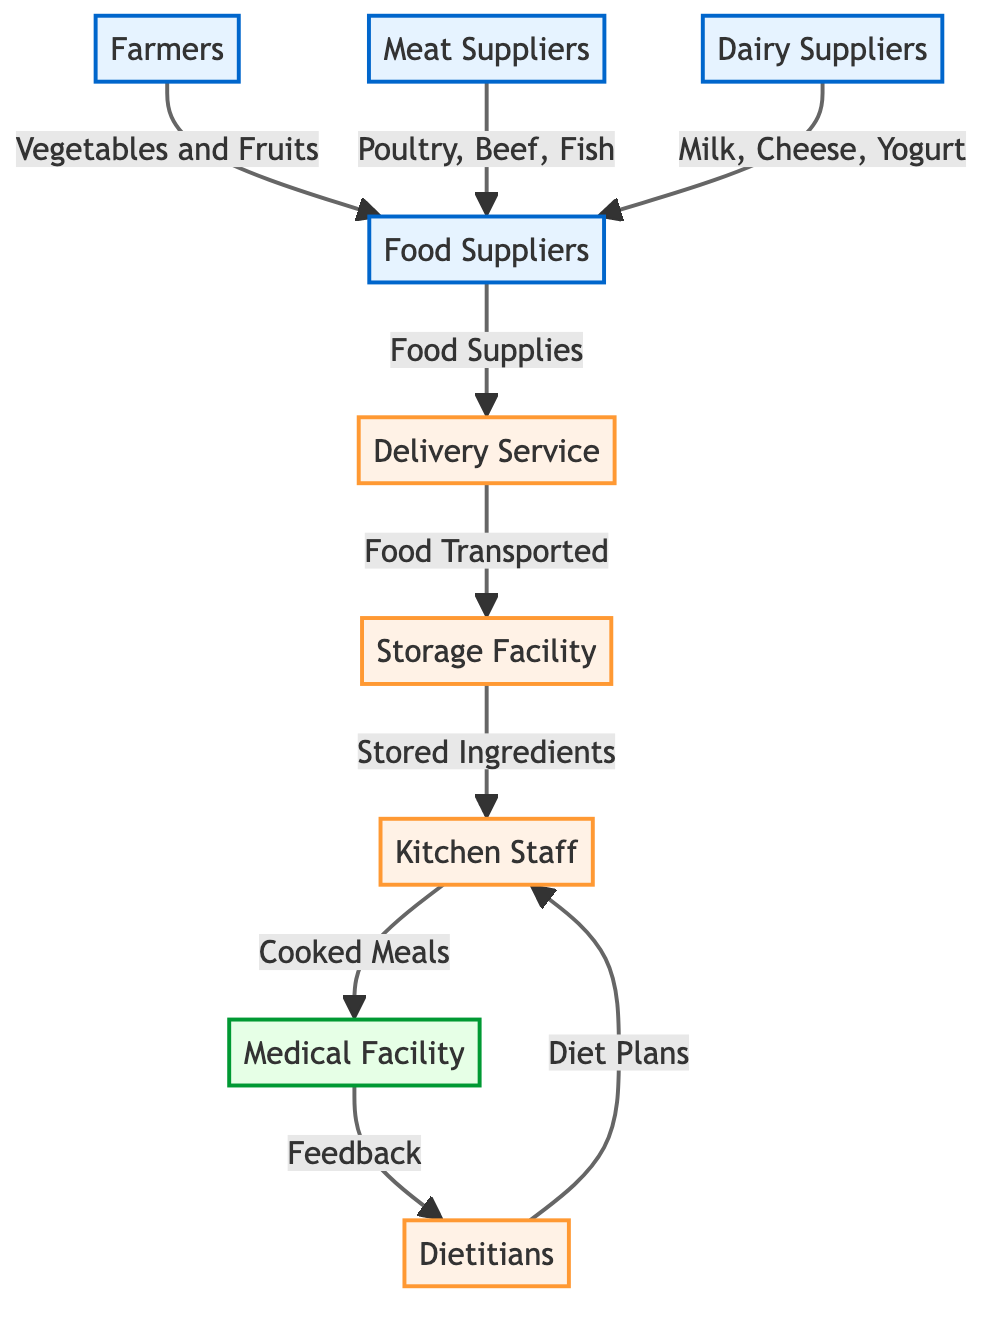What are the different types of suppliers in the diagram? The diagram displays three types of suppliers: Farmers, Meat Suppliers, and Dairy Suppliers. Each supplier contributes various food items to Food Suppliers.
Answer: Farmers, Meat Suppliers, Dairy Suppliers What does the flow from the Food Suppliers to the Delivery Service represent? This flow represents the transportation of food supplies from Food Suppliers to the Delivery Service, which is an essential step in ensuring meals reach the medical facility.
Answer: Food Supplies How many processes are shown in the diagram? The diagram shows four processes: Delivery Service, Storage Facility, Kitchen Staff, and Dietitians. This counts all the activities involved in meal preparation and organization.
Answer: 4 What ingredients do Farmers supply to Food Suppliers? Farmers supply Vegetables and Fruits to Food Suppliers, which are essential components of nutrition in the medical facility meals.
Answer: Vegetables and Fruits Which node receives feedback from the Medical Facility? The Medical Facility sends feedback to the Dietitians, allowing them to adjust diet plans based on the responses from the kitchen staff.
Answer: Dietitians What is transported from the Storage Facility to the Kitchen Staff? The Storage Facility supplies Stored Ingredients to the Kitchen Staff, which they use to prepare meals for patients.
Answer: Stored Ingredients Which suppliers provide cooked meals to the Medical Facility? The Kitchen Staff is responsible for providing the cooked meals to the Medical Facility after preparing ingredients received from the Storage Facility.
Answer: Kitchen Staff What role do Dietitians play in the food chain? Dietitians create diet plans that guide the Kitchen Staff in preparing meals to meet the nutritional needs of patients at the medical facility.
Answer: Diet Plans How do Dietitians receive feedback from the Medical Facility? The Medical Facility sends feedback to the Dietitians, which helps them adjust and improve future diet plans based on patient needs and meal success.
Answer: Feedback 